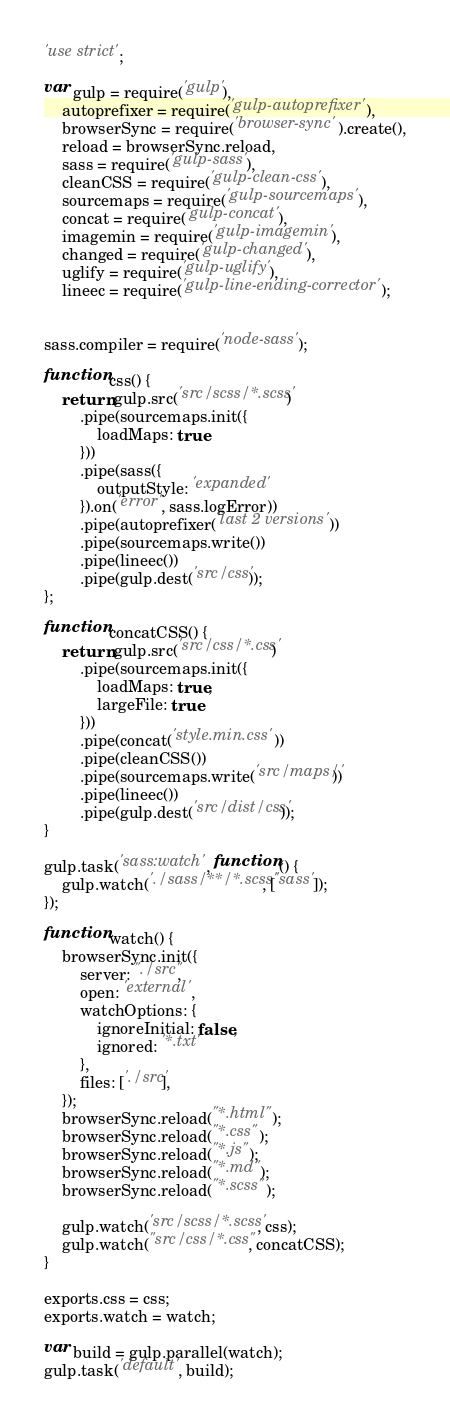<code> <loc_0><loc_0><loc_500><loc_500><_JavaScript_>'use strict';

var gulp = require('gulp'),
    autoprefixer = require('gulp-autoprefixer'),
    browserSync = require('browser-sync').create(),
    reload = browserSync.reload,
    sass = require('gulp-sass'),
    cleanCSS = require('gulp-clean-css'),
    sourcemaps = require('gulp-sourcemaps'),
    concat = require('gulp-concat'),
    imagemin = require('gulp-imagemin'),
    changed = require('gulp-changed'),
    uglify = require('gulp-uglify'),
    lineec = require('gulp-line-ending-corrector');


sass.compiler = require('node-sass');

function css() {
    return gulp.src('src/scss/*.scss')
        .pipe(sourcemaps.init({
            loadMaps: true
        }))
        .pipe(sass({
            outputStyle: 'expanded'
        }).on('error', sass.logError))
        .pipe(autoprefixer('last 2 versions'))
        .pipe(sourcemaps.write())
        .pipe(lineec())
        .pipe(gulp.dest('src/css'));
};

function concatCSS() {
    return gulp.src('src/css/*.css')
        .pipe(sourcemaps.init({
            loadMaps: true,
            largeFile: true
        }))
        .pipe(concat('style.min.css'))
        .pipe(cleanCSS())
        .pipe(sourcemaps.write('src/maps/'))
        .pipe(lineec())
        .pipe(gulp.dest('src/dist/css'));
}

gulp.task('sass:watch', function () {
    gulp.watch('./sass/**/*.scss', ['sass']);
});

function watch() {
    browserSync.init({
        server: "./src",
        open: 'external',
        watchOptions: {
            ignoreInitial: false,
            ignored: '*.txt'
        },
        files: ['./src'],
    });
    browserSync.reload("*.html");
    browserSync.reload("*.css");
    browserSync.reload("*.js");
    browserSync.reload("*.md");
    browserSync.reload("*.scss");

    gulp.watch('src/scss/*.scss', css);
    gulp.watch("src/css/*.css", concatCSS);
}

exports.css = css;
exports.watch = watch;

var build = gulp.parallel(watch);
gulp.task('default', build);</code> 